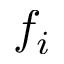<formula> <loc_0><loc_0><loc_500><loc_500>f _ { i }</formula> 